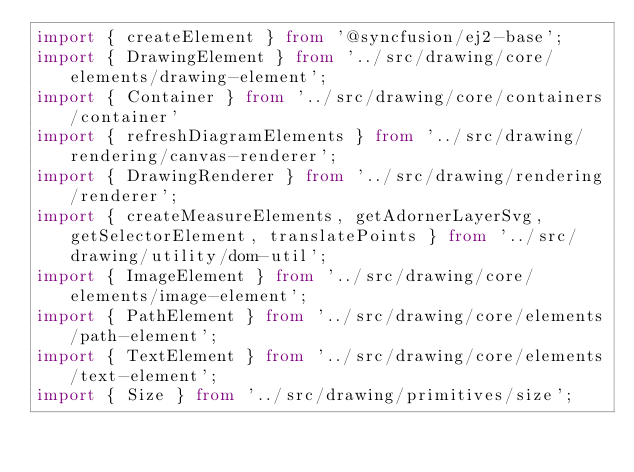<code> <loc_0><loc_0><loc_500><loc_500><_TypeScript_>import { createElement } from '@syncfusion/ej2-base';
import { DrawingElement } from '../src/drawing/core/elements/drawing-element';
import { Container } from '../src/drawing/core/containers/container'
import { refreshDiagramElements } from '../src/drawing/rendering/canvas-renderer';
import { DrawingRenderer } from '../src/drawing/rendering/renderer';
import { createMeasureElements, getAdornerLayerSvg, getSelectorElement, translatePoints } from '../src/drawing/utility/dom-util';
import { ImageElement } from '../src/drawing/core/elements/image-element';
import { PathElement } from '../src/drawing/core/elements/path-element';
import { TextElement } from '../src/drawing/core/elements/text-element';
import { Size } from '../src/drawing/primitives/size';</code> 